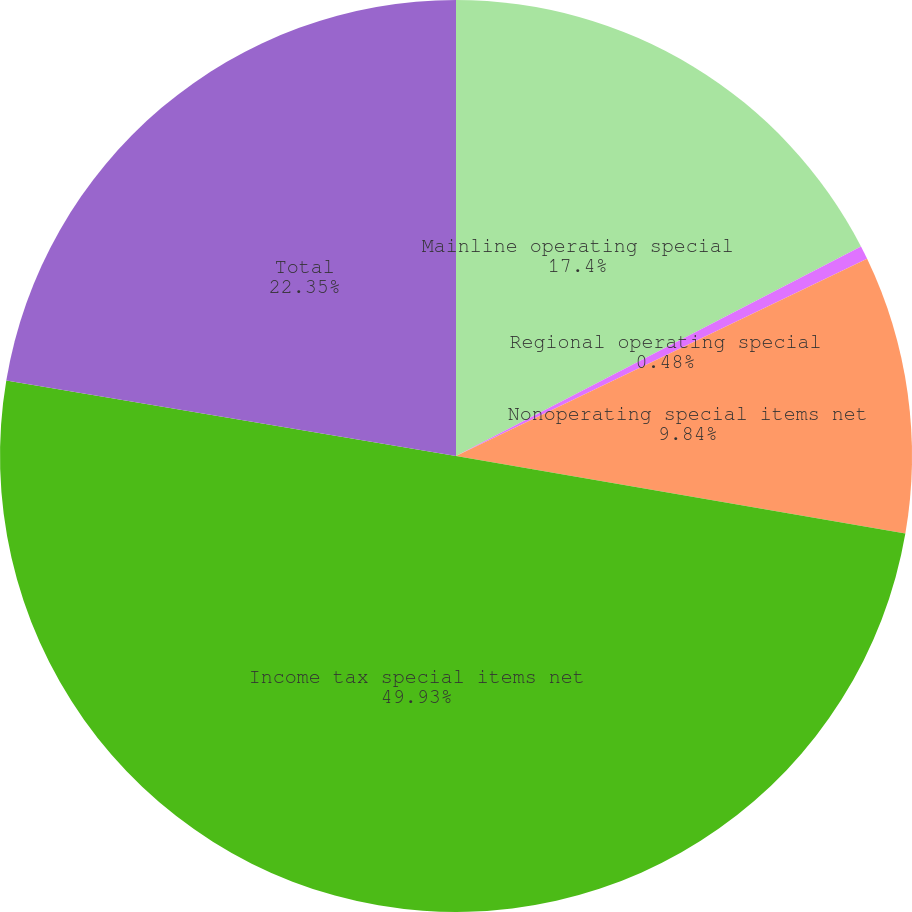Convert chart to OTSL. <chart><loc_0><loc_0><loc_500><loc_500><pie_chart><fcel>Mainline operating special<fcel>Regional operating special<fcel>Nonoperating special items net<fcel>Income tax special items net<fcel>Total<nl><fcel>17.4%<fcel>0.48%<fcel>9.84%<fcel>49.93%<fcel>22.35%<nl></chart> 